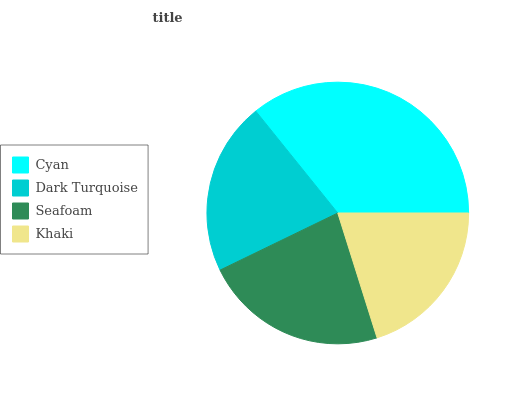Is Khaki the minimum?
Answer yes or no. Yes. Is Cyan the maximum?
Answer yes or no. Yes. Is Dark Turquoise the minimum?
Answer yes or no. No. Is Dark Turquoise the maximum?
Answer yes or no. No. Is Cyan greater than Dark Turquoise?
Answer yes or no. Yes. Is Dark Turquoise less than Cyan?
Answer yes or no. Yes. Is Dark Turquoise greater than Cyan?
Answer yes or no. No. Is Cyan less than Dark Turquoise?
Answer yes or no. No. Is Seafoam the high median?
Answer yes or no. Yes. Is Dark Turquoise the low median?
Answer yes or no. Yes. Is Cyan the high median?
Answer yes or no. No. Is Seafoam the low median?
Answer yes or no. No. 